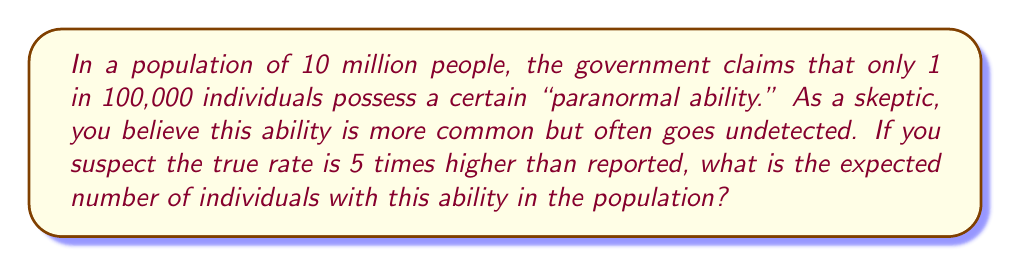Show me your answer to this math problem. Let's approach this step-by-step:

1) The reported rate is 1 in 100,000, which can be expressed as a probability:
   $p_{reported} = \frac{1}{100,000} = 0.00001$

2) We suspect the true rate is 5 times higher:
   $p_{true} = 5 \times p_{reported} = 5 \times 0.00001 = 0.00005$

3) The population size is 10 million:
   $N = 10,000,000$

4) To find the expected number of individuals with the ability, we multiply the population size by the probability:

   $E(X) = N \times p_{true}$

   Where $E(X)$ is the expected value (or mean) of the binomial distribution.

5) Substituting our values:

   $E(X) = 10,000,000 \times 0.00005 = 500$

Therefore, we would expect 500 individuals in the population to possess this ability.
Answer: 500 individuals 